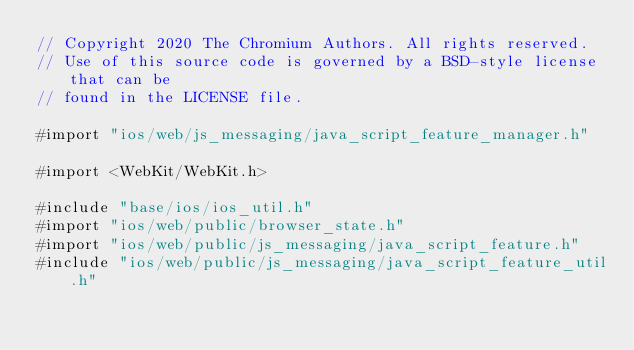<code> <loc_0><loc_0><loc_500><loc_500><_ObjectiveC_>// Copyright 2020 The Chromium Authors. All rights reserved.
// Use of this source code is governed by a BSD-style license that can be
// found in the LICENSE file.

#import "ios/web/js_messaging/java_script_feature_manager.h"

#import <WebKit/WebKit.h>

#include "base/ios/ios_util.h"
#import "ios/web/public/browser_state.h"
#import "ios/web/public/js_messaging/java_script_feature.h"
#include "ios/web/public/js_messaging/java_script_feature_util.h"
</code> 